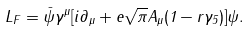Convert formula to latex. <formula><loc_0><loc_0><loc_500><loc_500>L _ { F } = \bar { \psi } \gamma ^ { \mu } [ i \partial _ { \mu } + e \sqrt { \pi } A _ { \mu } ( 1 - r \gamma _ { 5 } ) ] \psi .</formula> 